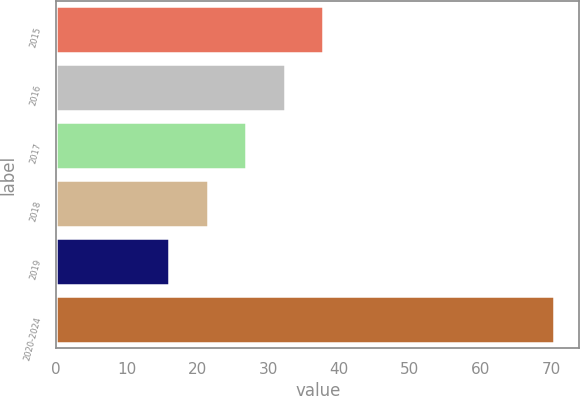Convert chart to OTSL. <chart><loc_0><loc_0><loc_500><loc_500><bar_chart><fcel>2015<fcel>2016<fcel>2017<fcel>2018<fcel>2019<fcel>2020-2024<nl><fcel>37.8<fcel>32.35<fcel>26.9<fcel>21.45<fcel>16<fcel>70.5<nl></chart> 